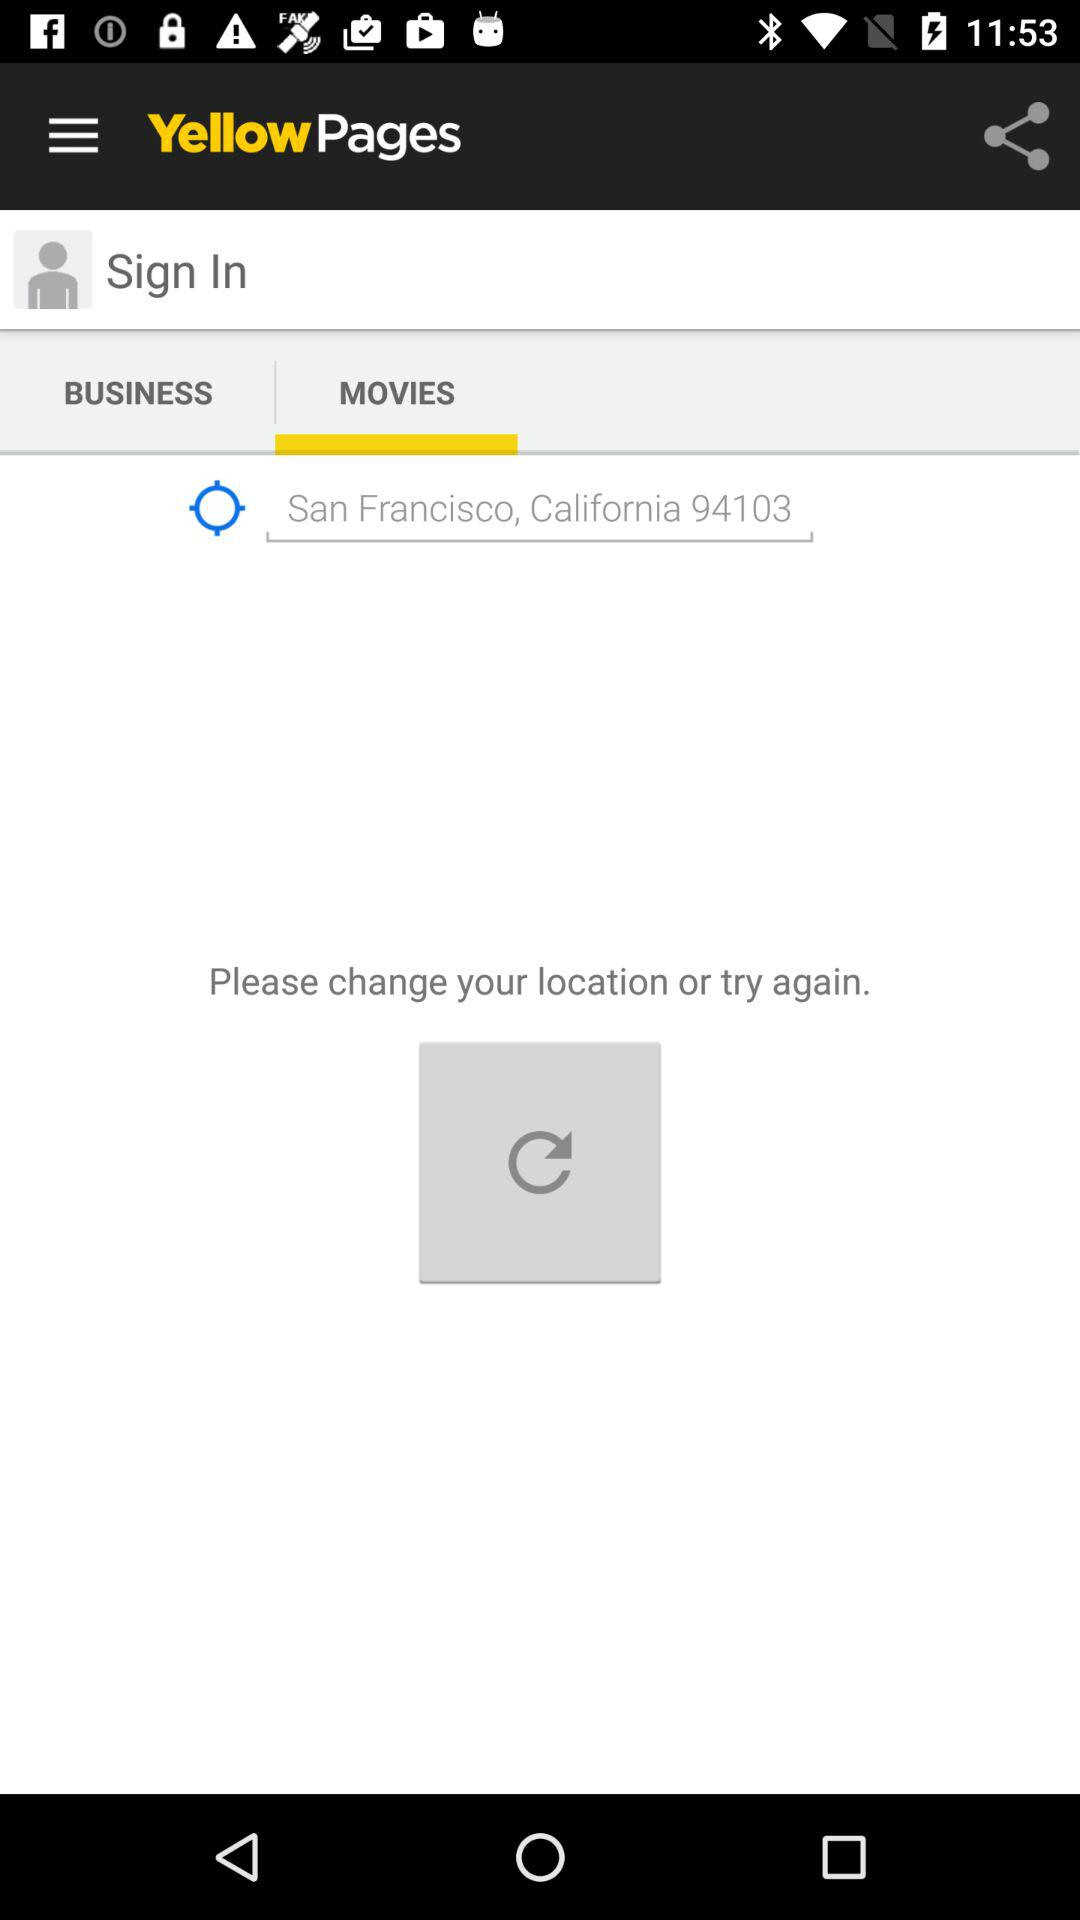Which tab is selected? The selected tab is "MOVIES". 